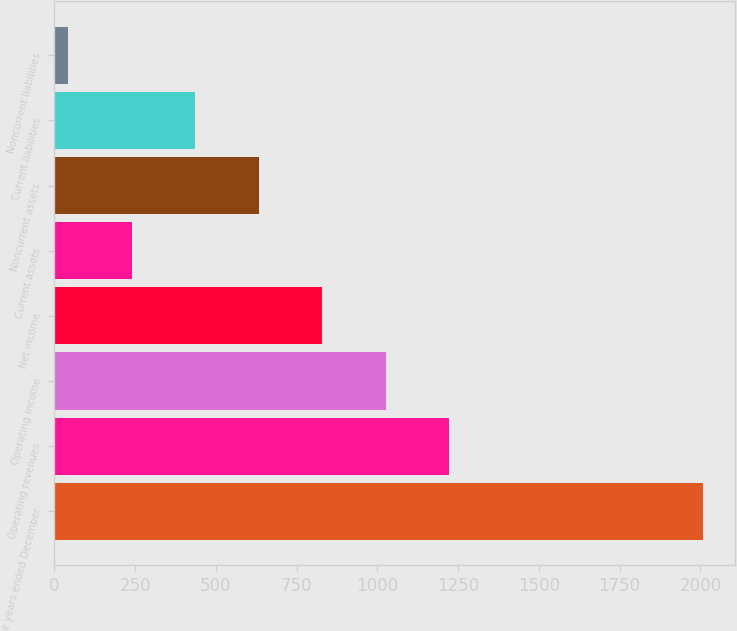<chart> <loc_0><loc_0><loc_500><loc_500><bar_chart><fcel>For the years ended December<fcel>Operating revenues<fcel>Operating income<fcel>Net income<fcel>Current assets<fcel>Noncurrent assets<fcel>Current liabilities<fcel>Noncurrent liabilities<nl><fcel>2008<fcel>1222<fcel>1025.5<fcel>829<fcel>239.5<fcel>632.5<fcel>436<fcel>43<nl></chart> 